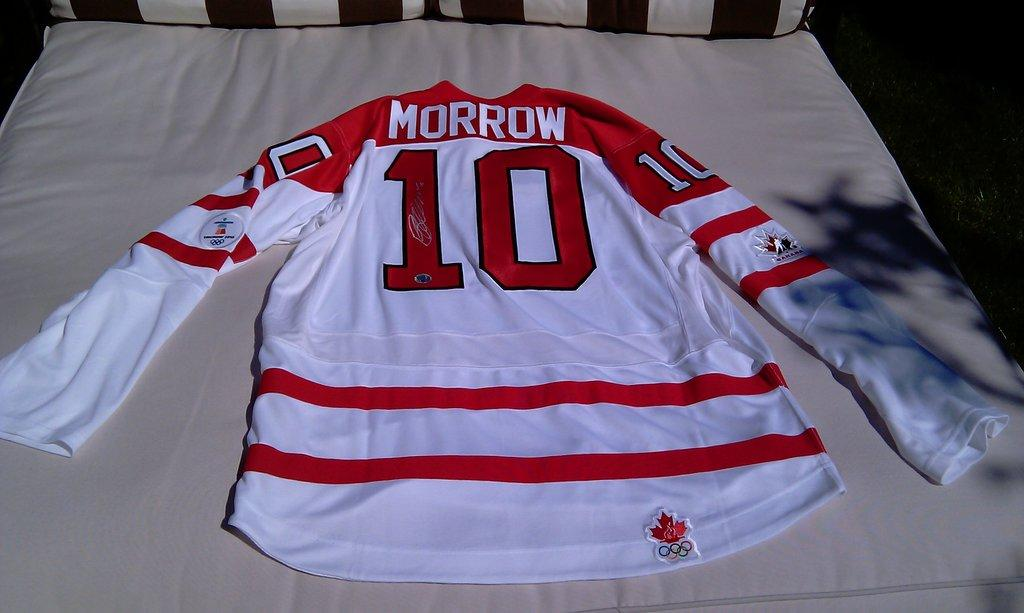<image>
Render a clear and concise summary of the photo. A Morrow hockey jersey laying on a bed. 